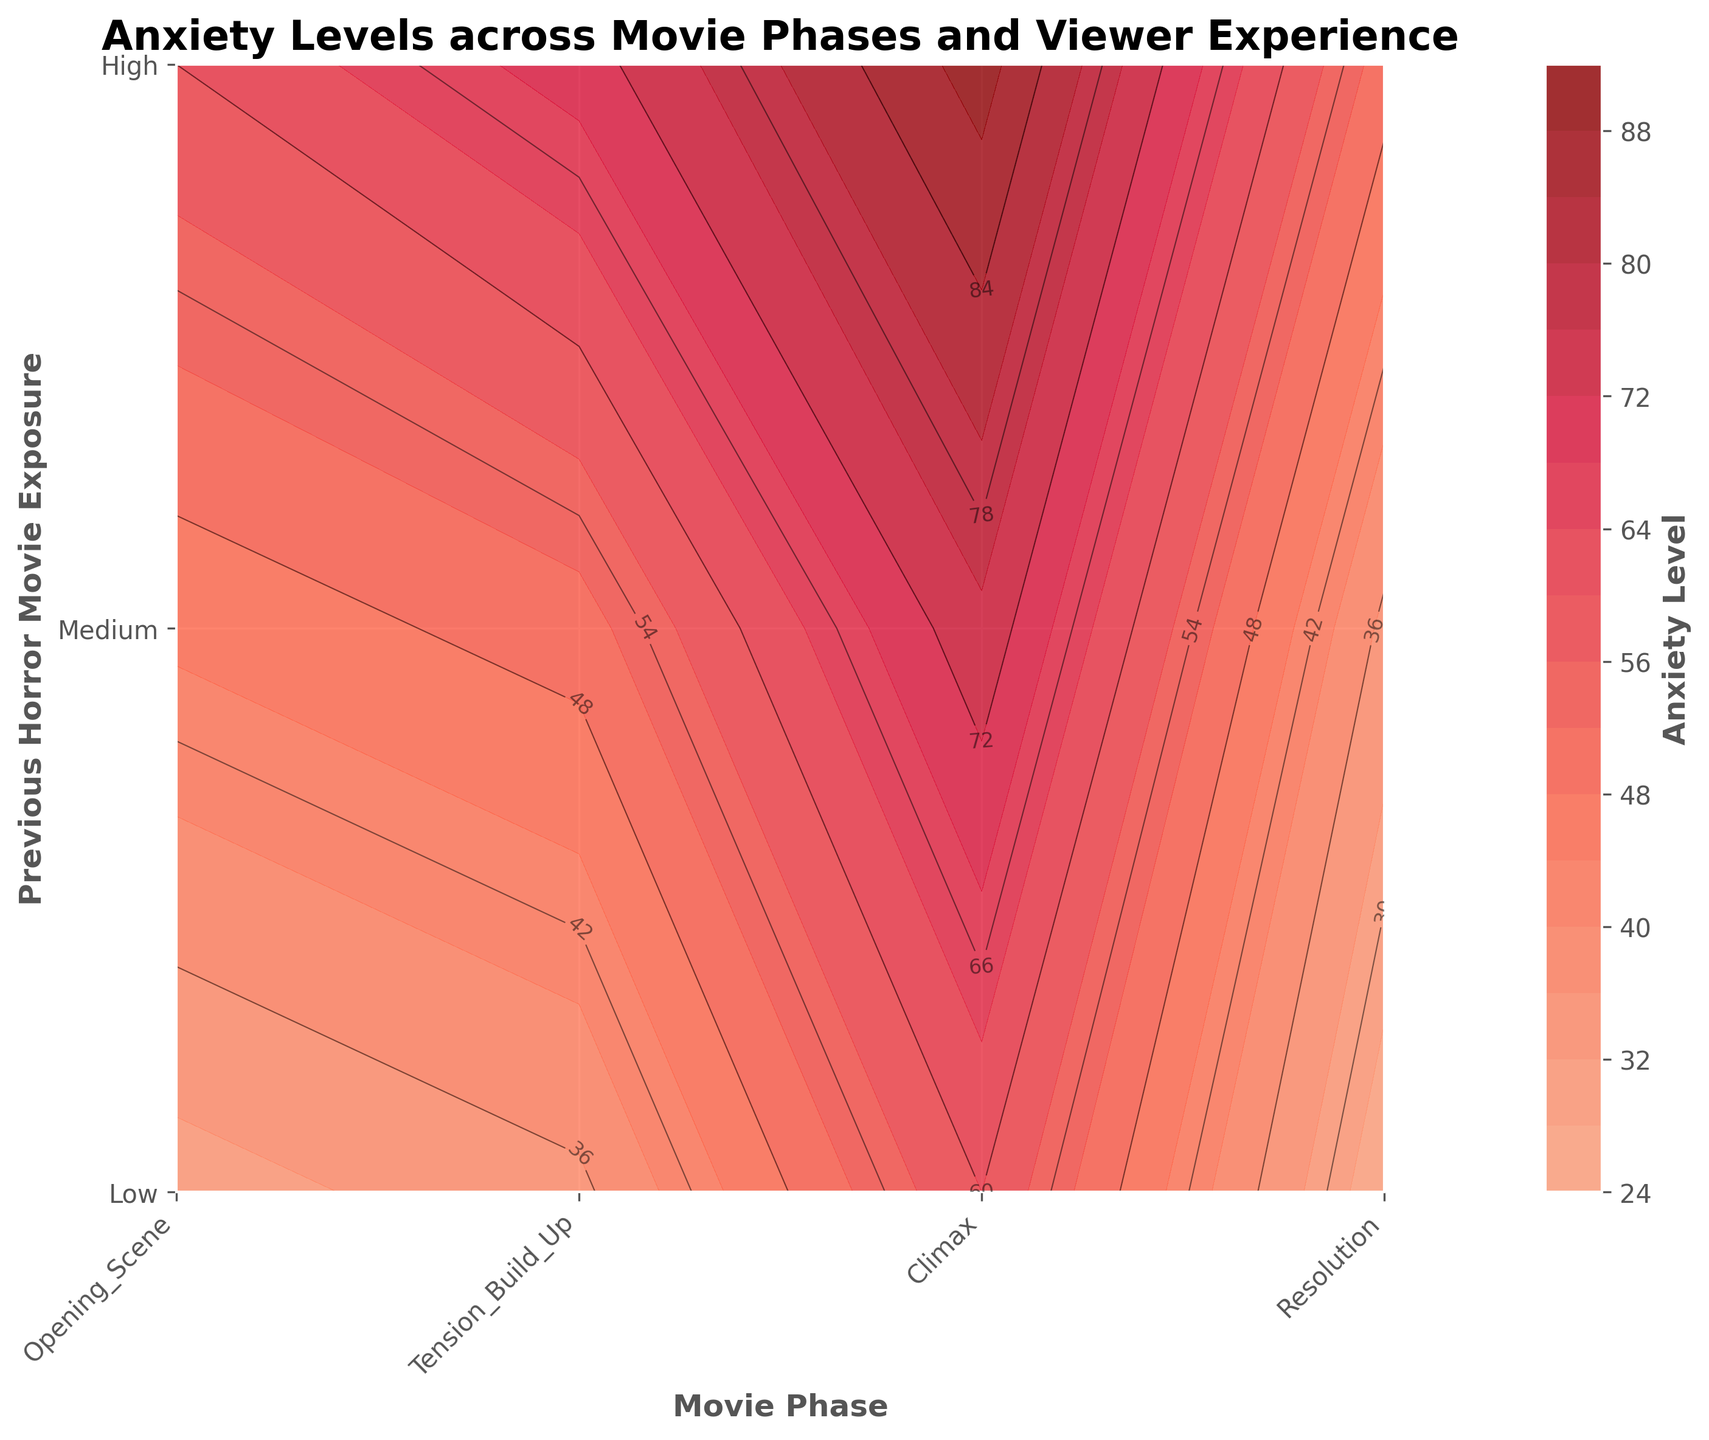What is the title of the plot? The title is usually positioned at the top of the plot and gives an overview of what the plot represents. The title of this plot reads 'Anxiety Levels across Movie Phases and Viewer Experience.'
Answer: Anxiety Levels across Movie Phases and Viewer Experience What is the y-axis label of the plot? The y-axis label is typically found alongside the y-axis and denotes what is being measured or compared. In this plot, the y-axis label is 'Previous Horror Movie Exposure.'
Answer: Previous Horror Movie Exposure Which movie phase corresponds to the highest anxiety level for viewers with high exposure to horror movies? To find this, you look at the 'High' exposure row and identify which movie phase overlaps with the darkest color or highest contour label. The 'Climax' phase corresponds to the highest anxiety level of 90.
Answer: Climax What is the anxiety level for viewers with medium previous horror movie exposure during the resolution phase? Locate the 'Resolution' phase on the x-axis and follow vertically to the 'Medium' exposure level row. The corresponding anxiety level is labeled as 35.
Answer: 35 What is the difference in anxiety levels between viewers with low and high exposure during the tension build-up phase? Identify the anxiety levels for the 'Tension Build-Up' phase for both 'Low' and 'High' exposure levels: 35 and 70 respectively. Subtract the lower value from the higher (70 - 35).
Answer: 35 How does the anxiety level change from the opening scene to the resolution phase for viewers with medium exposure? Locate the medium exposure row and compare anxiety levels at 'Opening Scene' and 'Resolution': 45 and 35. Calculate the difference (45 - 35).
Answer: -10 Which phase shows the greatest variability in anxiety levels across different exposure levels? Compare the range of anxiety levels (difference between highest and lowest) for each phase. 'Climax' has the largest variability, with levels ranging from 60 to 90.
Answer: Climax What is the average anxiety level during the climax phase across all exposure levels? Find the anxiety levels for 'Climax' phase: 60 (Low), 75 (Medium), 90 (High). Calculate the average by summing and dividing by three: (60 + 75 + 90) / 3.
Answer: 75 For which exposure level do the anxiety levels show the least fluctuation across all movie phases? Compare the range of anxiety levels for each exposure level across the movie phases. 'Medium' exposure shows the least fluctuation, with levels ranging from 35 to 75 (a range of 40).
Answer: Medium Is the anxiety level more affected by the movie phase or by the previous horror movie exposure level? Observe the contour patterns and levels. The anxiety level changes more drastically across movie phases (e.g., Resolution to Climax) than across exposure levels at a given phase.
Answer: Movie phase 